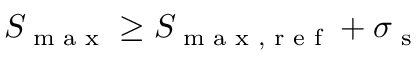<formula> <loc_0><loc_0><loc_500><loc_500>S _ { \max } \geq S _ { \max , r e f } + \sigma _ { s }</formula> 